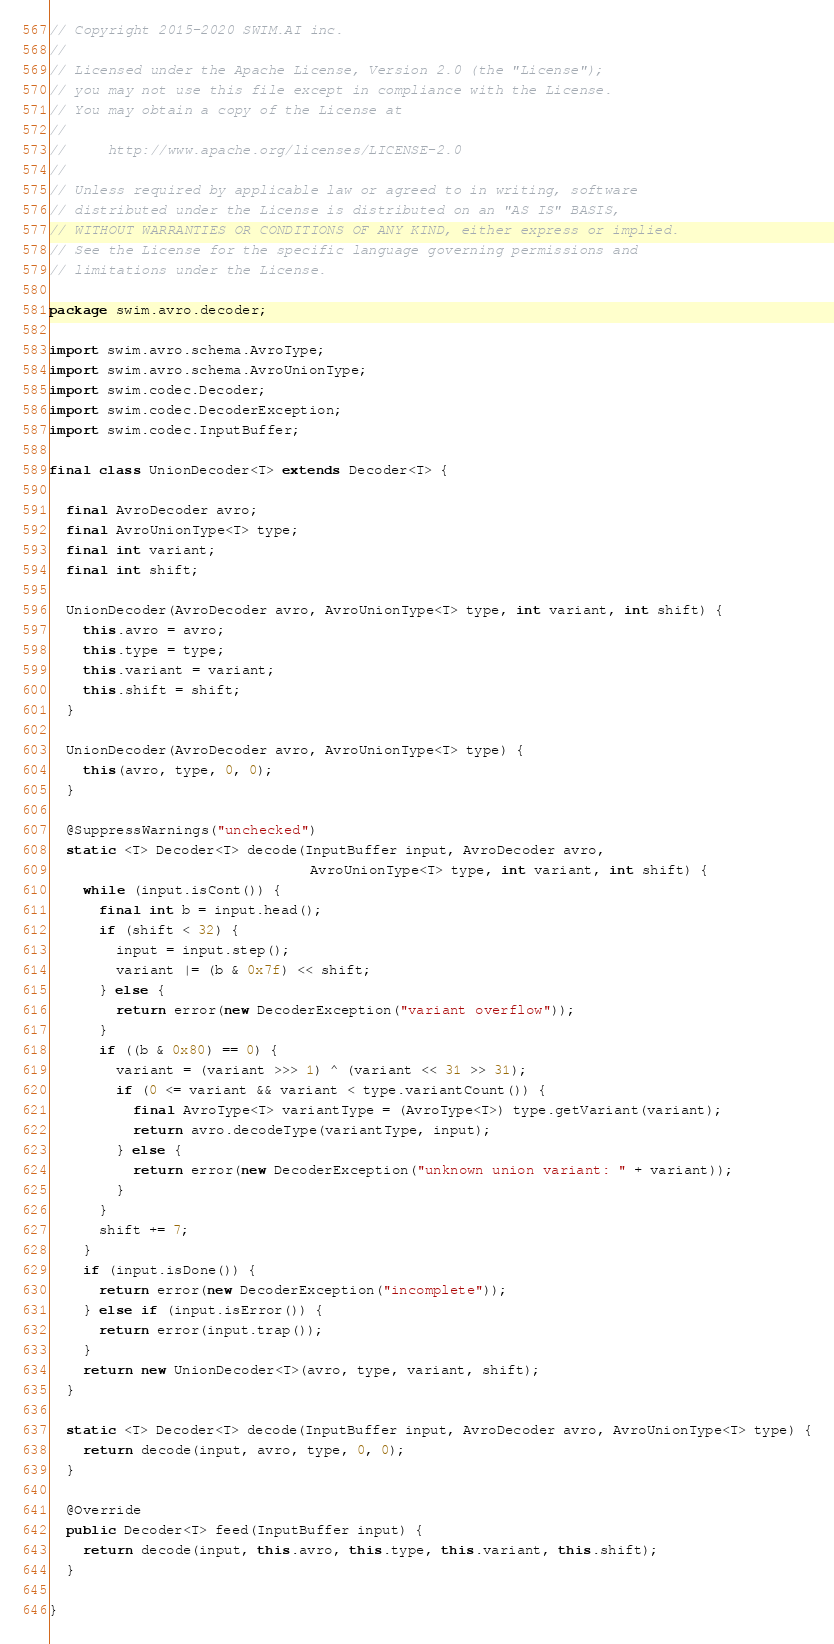<code> <loc_0><loc_0><loc_500><loc_500><_Java_>// Copyright 2015-2020 SWIM.AI inc.
//
// Licensed under the Apache License, Version 2.0 (the "License");
// you may not use this file except in compliance with the License.
// You may obtain a copy of the License at
//
//     http://www.apache.org/licenses/LICENSE-2.0
//
// Unless required by applicable law or agreed to in writing, software
// distributed under the License is distributed on an "AS IS" BASIS,
// WITHOUT WARRANTIES OR CONDITIONS OF ANY KIND, either express or implied.
// See the License for the specific language governing permissions and
// limitations under the License.

package swim.avro.decoder;

import swim.avro.schema.AvroType;
import swim.avro.schema.AvroUnionType;
import swim.codec.Decoder;
import swim.codec.DecoderException;
import swim.codec.InputBuffer;

final class UnionDecoder<T> extends Decoder<T> {

  final AvroDecoder avro;
  final AvroUnionType<T> type;
  final int variant;
  final int shift;

  UnionDecoder(AvroDecoder avro, AvroUnionType<T> type, int variant, int shift) {
    this.avro = avro;
    this.type = type;
    this.variant = variant;
    this.shift = shift;
  }

  UnionDecoder(AvroDecoder avro, AvroUnionType<T> type) {
    this(avro, type, 0, 0);
  }

  @SuppressWarnings("unchecked")
  static <T> Decoder<T> decode(InputBuffer input, AvroDecoder avro,
                               AvroUnionType<T> type, int variant, int shift) {
    while (input.isCont()) {
      final int b = input.head();
      if (shift < 32) {
        input = input.step();
        variant |= (b & 0x7f) << shift;
      } else {
        return error(new DecoderException("variant overflow"));
      }
      if ((b & 0x80) == 0) {
        variant = (variant >>> 1) ^ (variant << 31 >> 31);
        if (0 <= variant && variant < type.variantCount()) {
          final AvroType<T> variantType = (AvroType<T>) type.getVariant(variant);
          return avro.decodeType(variantType, input);
        } else {
          return error(new DecoderException("unknown union variant: " + variant));
        }
      }
      shift += 7;
    }
    if (input.isDone()) {
      return error(new DecoderException("incomplete"));
    } else if (input.isError()) {
      return error(input.trap());
    }
    return new UnionDecoder<T>(avro, type, variant, shift);
  }

  static <T> Decoder<T> decode(InputBuffer input, AvroDecoder avro, AvroUnionType<T> type) {
    return decode(input, avro, type, 0, 0);
  }

  @Override
  public Decoder<T> feed(InputBuffer input) {
    return decode(input, this.avro, this.type, this.variant, this.shift);
  }

}
</code> 